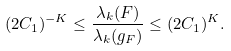<formula> <loc_0><loc_0><loc_500><loc_500>( 2 C _ { 1 } ) ^ { - K } \leq \frac { \lambda _ { k } ( F ) } { \lambda _ { k } ( g _ { F } ) } \leq ( 2 C _ { 1 } ) ^ { K } .</formula> 